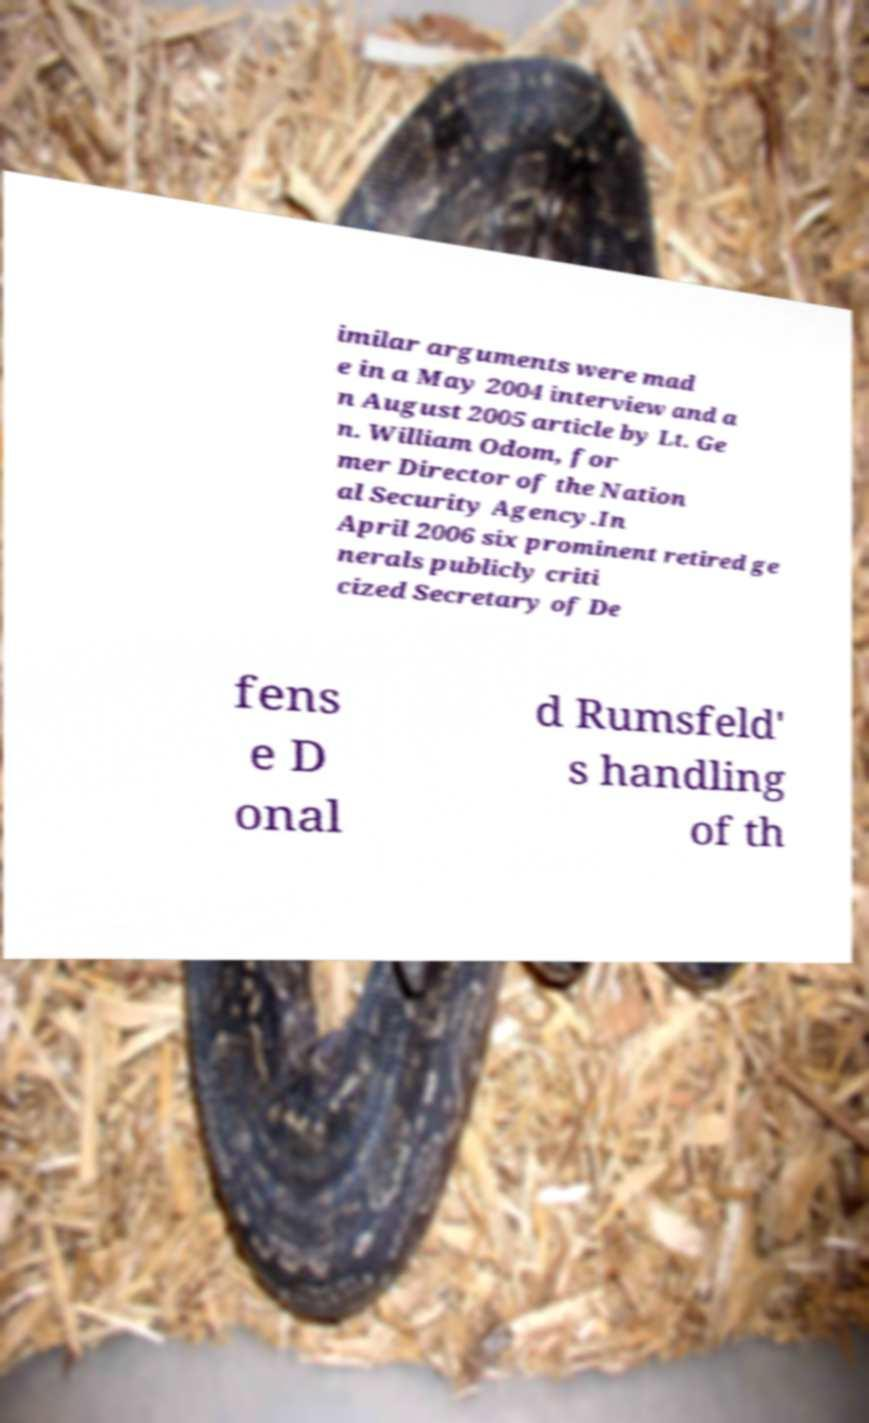There's text embedded in this image that I need extracted. Can you transcribe it verbatim? imilar arguments were mad e in a May 2004 interview and a n August 2005 article by Lt. Ge n. William Odom, for mer Director of the Nation al Security Agency.In April 2006 six prominent retired ge nerals publicly criti cized Secretary of De fens e D onal d Rumsfeld' s handling of th 